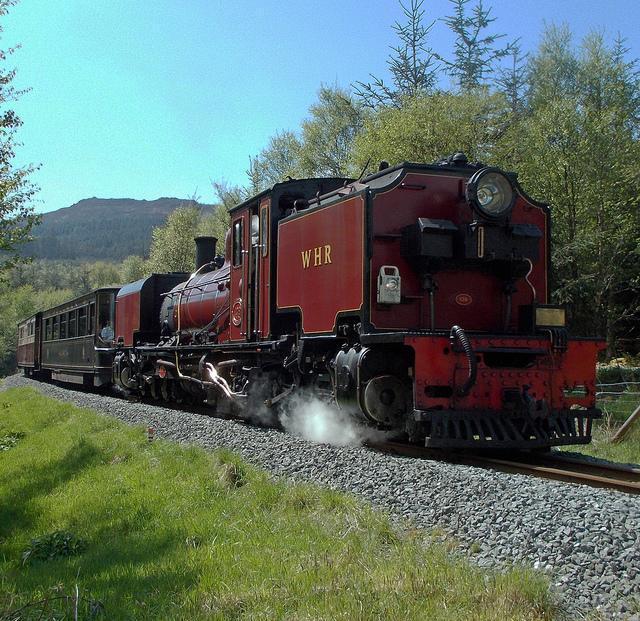How many tracks are seen?
Give a very brief answer. 1. 